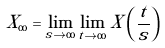<formula> <loc_0><loc_0><loc_500><loc_500>X _ { \infty } = \lim _ { s \to \infty } \lim _ { t \to \infty } X \left ( \frac { t } { s } \right )</formula> 